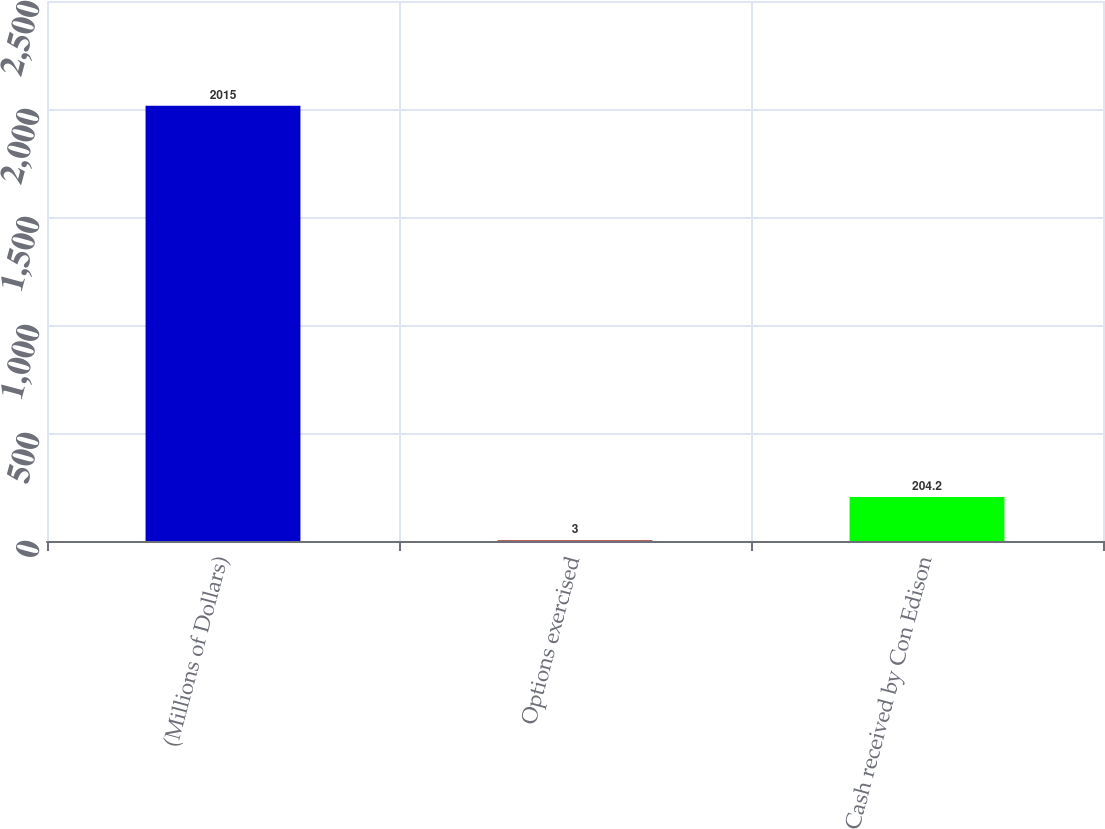Convert chart to OTSL. <chart><loc_0><loc_0><loc_500><loc_500><bar_chart><fcel>(Millions of Dollars)<fcel>Options exercised<fcel>Cash received by Con Edison<nl><fcel>2015<fcel>3<fcel>204.2<nl></chart> 